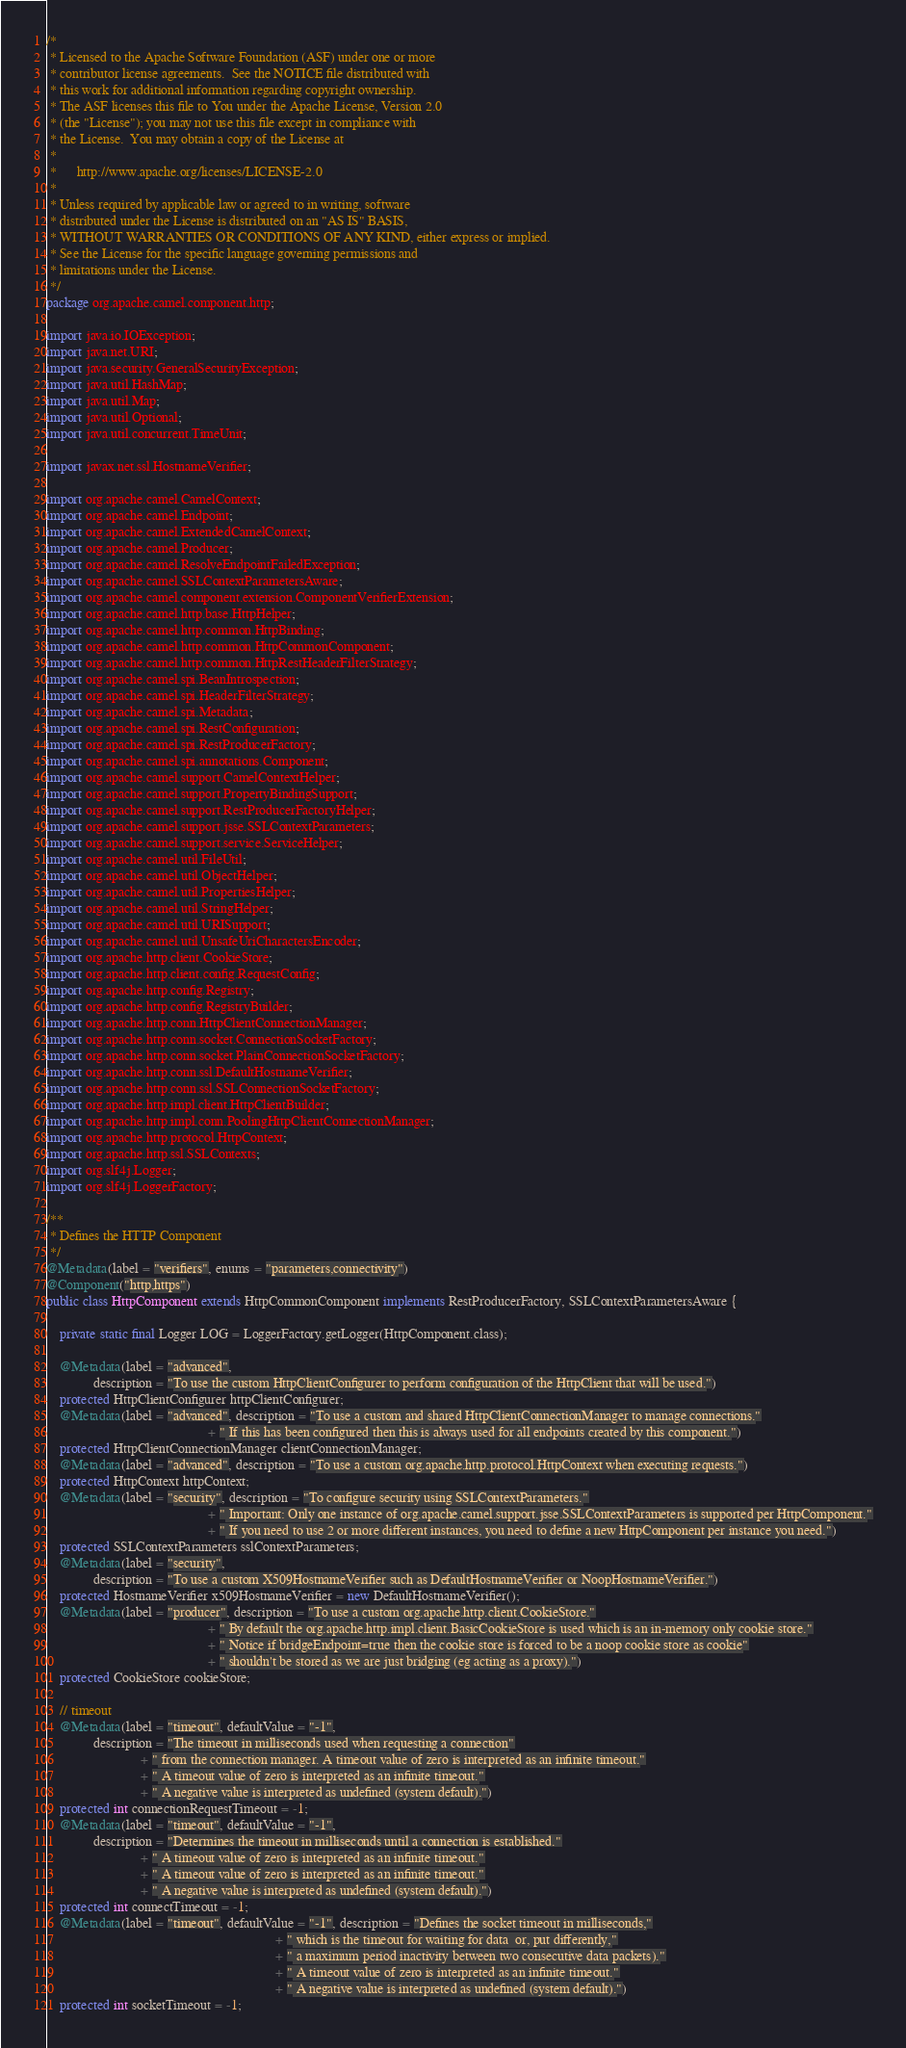<code> <loc_0><loc_0><loc_500><loc_500><_Java_>/*
 * Licensed to the Apache Software Foundation (ASF) under one or more
 * contributor license agreements.  See the NOTICE file distributed with
 * this work for additional information regarding copyright ownership.
 * The ASF licenses this file to You under the Apache License, Version 2.0
 * (the "License"); you may not use this file except in compliance with
 * the License.  You may obtain a copy of the License at
 *
 *      http://www.apache.org/licenses/LICENSE-2.0
 *
 * Unless required by applicable law or agreed to in writing, software
 * distributed under the License is distributed on an "AS IS" BASIS,
 * WITHOUT WARRANTIES OR CONDITIONS OF ANY KIND, either express or implied.
 * See the License for the specific language governing permissions and
 * limitations under the License.
 */
package org.apache.camel.component.http;

import java.io.IOException;
import java.net.URI;
import java.security.GeneralSecurityException;
import java.util.HashMap;
import java.util.Map;
import java.util.Optional;
import java.util.concurrent.TimeUnit;

import javax.net.ssl.HostnameVerifier;

import org.apache.camel.CamelContext;
import org.apache.camel.Endpoint;
import org.apache.camel.ExtendedCamelContext;
import org.apache.camel.Producer;
import org.apache.camel.ResolveEndpointFailedException;
import org.apache.camel.SSLContextParametersAware;
import org.apache.camel.component.extension.ComponentVerifierExtension;
import org.apache.camel.http.base.HttpHelper;
import org.apache.camel.http.common.HttpBinding;
import org.apache.camel.http.common.HttpCommonComponent;
import org.apache.camel.http.common.HttpRestHeaderFilterStrategy;
import org.apache.camel.spi.BeanIntrospection;
import org.apache.camel.spi.HeaderFilterStrategy;
import org.apache.camel.spi.Metadata;
import org.apache.camel.spi.RestConfiguration;
import org.apache.camel.spi.RestProducerFactory;
import org.apache.camel.spi.annotations.Component;
import org.apache.camel.support.CamelContextHelper;
import org.apache.camel.support.PropertyBindingSupport;
import org.apache.camel.support.RestProducerFactoryHelper;
import org.apache.camel.support.jsse.SSLContextParameters;
import org.apache.camel.support.service.ServiceHelper;
import org.apache.camel.util.FileUtil;
import org.apache.camel.util.ObjectHelper;
import org.apache.camel.util.PropertiesHelper;
import org.apache.camel.util.StringHelper;
import org.apache.camel.util.URISupport;
import org.apache.camel.util.UnsafeUriCharactersEncoder;
import org.apache.http.client.CookieStore;
import org.apache.http.client.config.RequestConfig;
import org.apache.http.config.Registry;
import org.apache.http.config.RegistryBuilder;
import org.apache.http.conn.HttpClientConnectionManager;
import org.apache.http.conn.socket.ConnectionSocketFactory;
import org.apache.http.conn.socket.PlainConnectionSocketFactory;
import org.apache.http.conn.ssl.DefaultHostnameVerifier;
import org.apache.http.conn.ssl.SSLConnectionSocketFactory;
import org.apache.http.impl.client.HttpClientBuilder;
import org.apache.http.impl.conn.PoolingHttpClientConnectionManager;
import org.apache.http.protocol.HttpContext;
import org.apache.http.ssl.SSLContexts;
import org.slf4j.Logger;
import org.slf4j.LoggerFactory;

/**
 * Defines the HTTP Component
 */
@Metadata(label = "verifiers", enums = "parameters,connectivity")
@Component("http,https")
public class HttpComponent extends HttpCommonComponent implements RestProducerFactory, SSLContextParametersAware {

    private static final Logger LOG = LoggerFactory.getLogger(HttpComponent.class);

    @Metadata(label = "advanced",
              description = "To use the custom HttpClientConfigurer to perform configuration of the HttpClient that will be used.")
    protected HttpClientConfigurer httpClientConfigurer;
    @Metadata(label = "advanced", description = "To use a custom and shared HttpClientConnectionManager to manage connections."
                                                + " If this has been configured then this is always used for all endpoints created by this component.")
    protected HttpClientConnectionManager clientConnectionManager;
    @Metadata(label = "advanced", description = "To use a custom org.apache.http.protocol.HttpContext when executing requests.")
    protected HttpContext httpContext;
    @Metadata(label = "security", description = "To configure security using SSLContextParameters."
                                                + " Important: Only one instance of org.apache.camel.support.jsse.SSLContextParameters is supported per HttpComponent."
                                                + " If you need to use 2 or more different instances, you need to define a new HttpComponent per instance you need.")
    protected SSLContextParameters sslContextParameters;
    @Metadata(label = "security",
              description = "To use a custom X509HostnameVerifier such as DefaultHostnameVerifier or NoopHostnameVerifier.")
    protected HostnameVerifier x509HostnameVerifier = new DefaultHostnameVerifier();
    @Metadata(label = "producer", description = "To use a custom org.apache.http.client.CookieStore."
                                                + " By default the org.apache.http.impl.client.BasicCookieStore is used which is an in-memory only cookie store."
                                                + " Notice if bridgeEndpoint=true then the cookie store is forced to be a noop cookie store as cookie"
                                                + " shouldn't be stored as we are just bridging (eg acting as a proxy).")
    protected CookieStore cookieStore;

    // timeout
    @Metadata(label = "timeout", defaultValue = "-1",
              description = "The timeout in milliseconds used when requesting a connection"
                            + " from the connection manager. A timeout value of zero is interpreted as an infinite timeout."
                            + " A timeout value of zero is interpreted as an infinite timeout."
                            + " A negative value is interpreted as undefined (system default).")
    protected int connectionRequestTimeout = -1;
    @Metadata(label = "timeout", defaultValue = "-1",
              description = "Determines the timeout in milliseconds until a connection is established."
                            + " A timeout value of zero is interpreted as an infinite timeout."
                            + " A timeout value of zero is interpreted as an infinite timeout."
                            + " A negative value is interpreted as undefined (system default).")
    protected int connectTimeout = -1;
    @Metadata(label = "timeout", defaultValue = "-1", description = "Defines the socket timeout in milliseconds,"
                                                                    + " which is the timeout for waiting for data  or, put differently,"
                                                                    + " a maximum period inactivity between two consecutive data packets)."
                                                                    + " A timeout value of zero is interpreted as an infinite timeout."
                                                                    + " A negative value is interpreted as undefined (system default).")
    protected int socketTimeout = -1;
</code> 